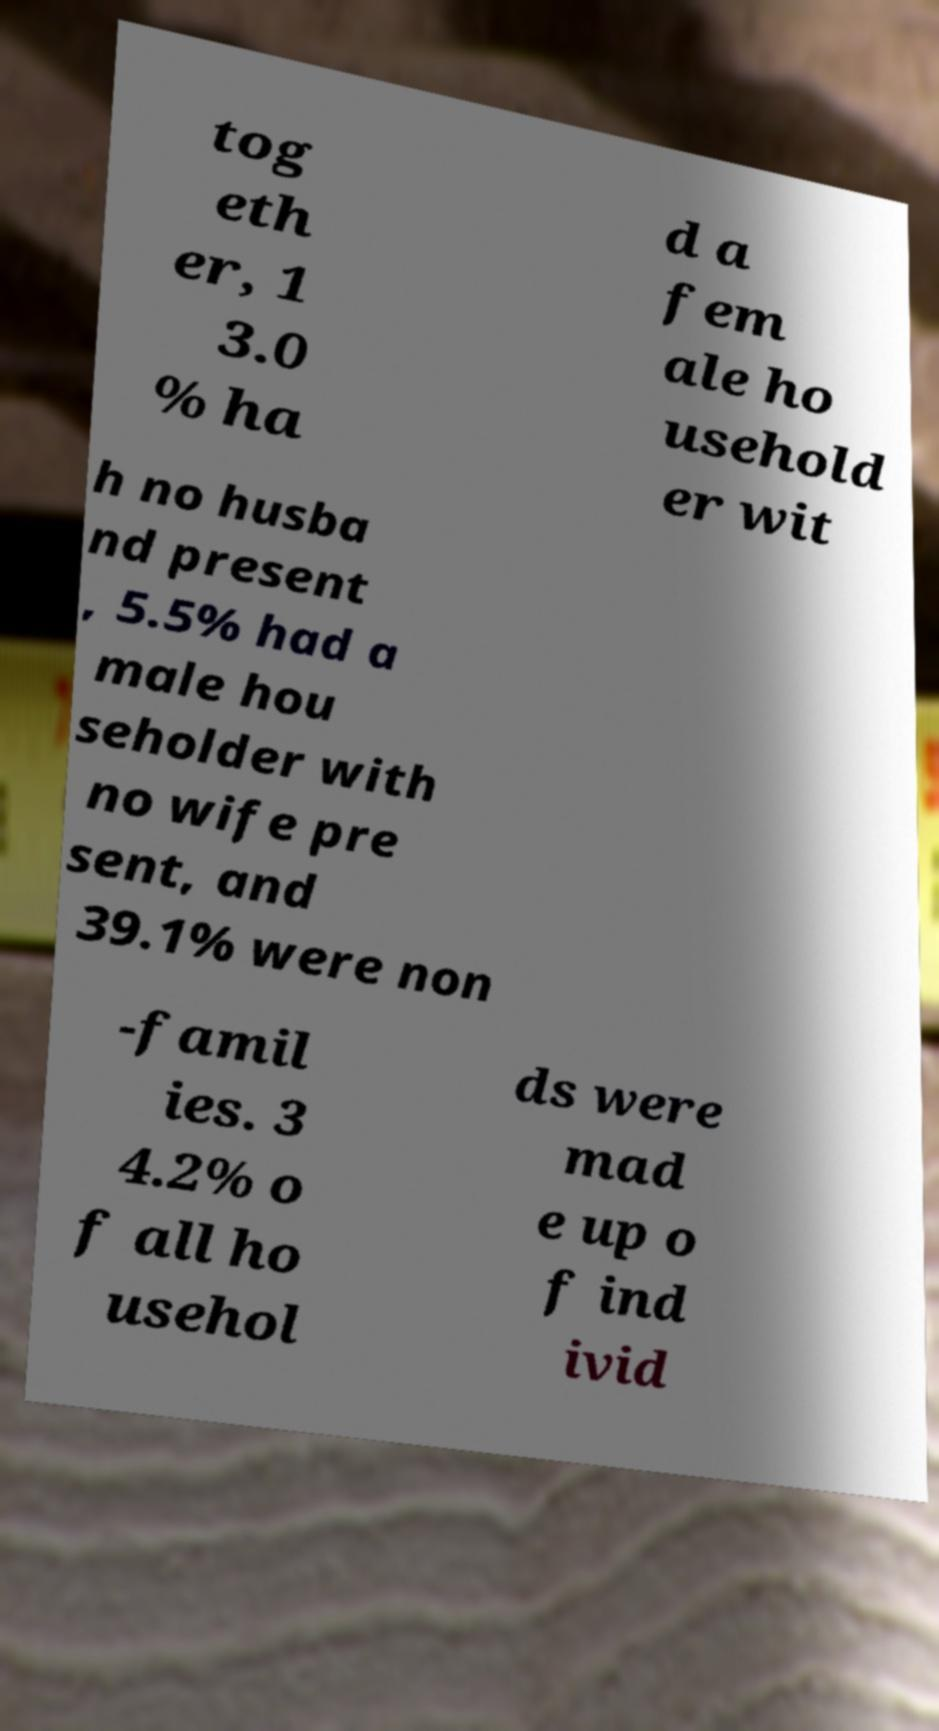Could you assist in decoding the text presented in this image and type it out clearly? tog eth er, 1 3.0 % ha d a fem ale ho usehold er wit h no husba nd present , 5.5% had a male hou seholder with no wife pre sent, and 39.1% were non -famil ies. 3 4.2% o f all ho usehol ds were mad e up o f ind ivid 